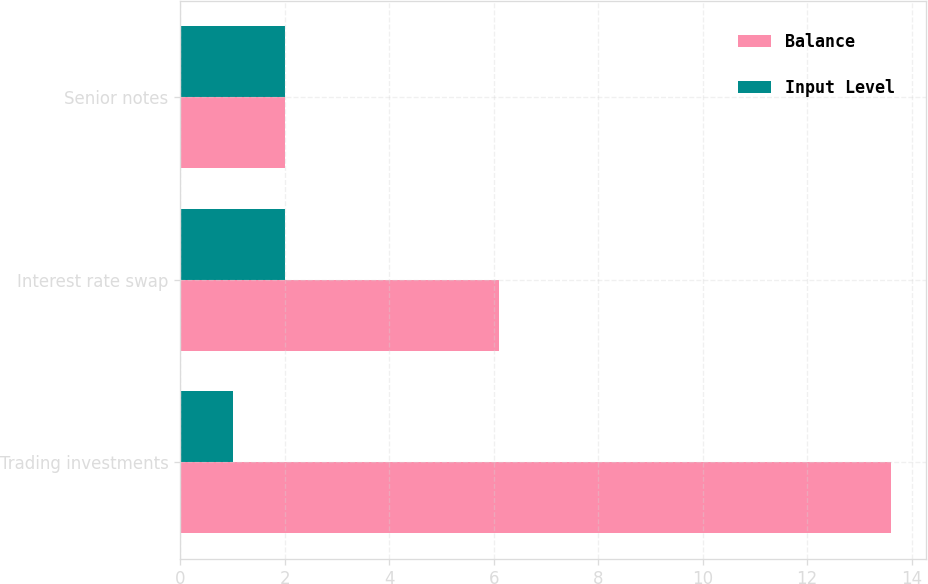<chart> <loc_0><loc_0><loc_500><loc_500><stacked_bar_chart><ecel><fcel>Trading investments<fcel>Interest rate swap<fcel>Senior notes<nl><fcel>Balance<fcel>13.6<fcel>6.1<fcel>2<nl><fcel>Input Level<fcel>1<fcel>2<fcel>2<nl></chart> 